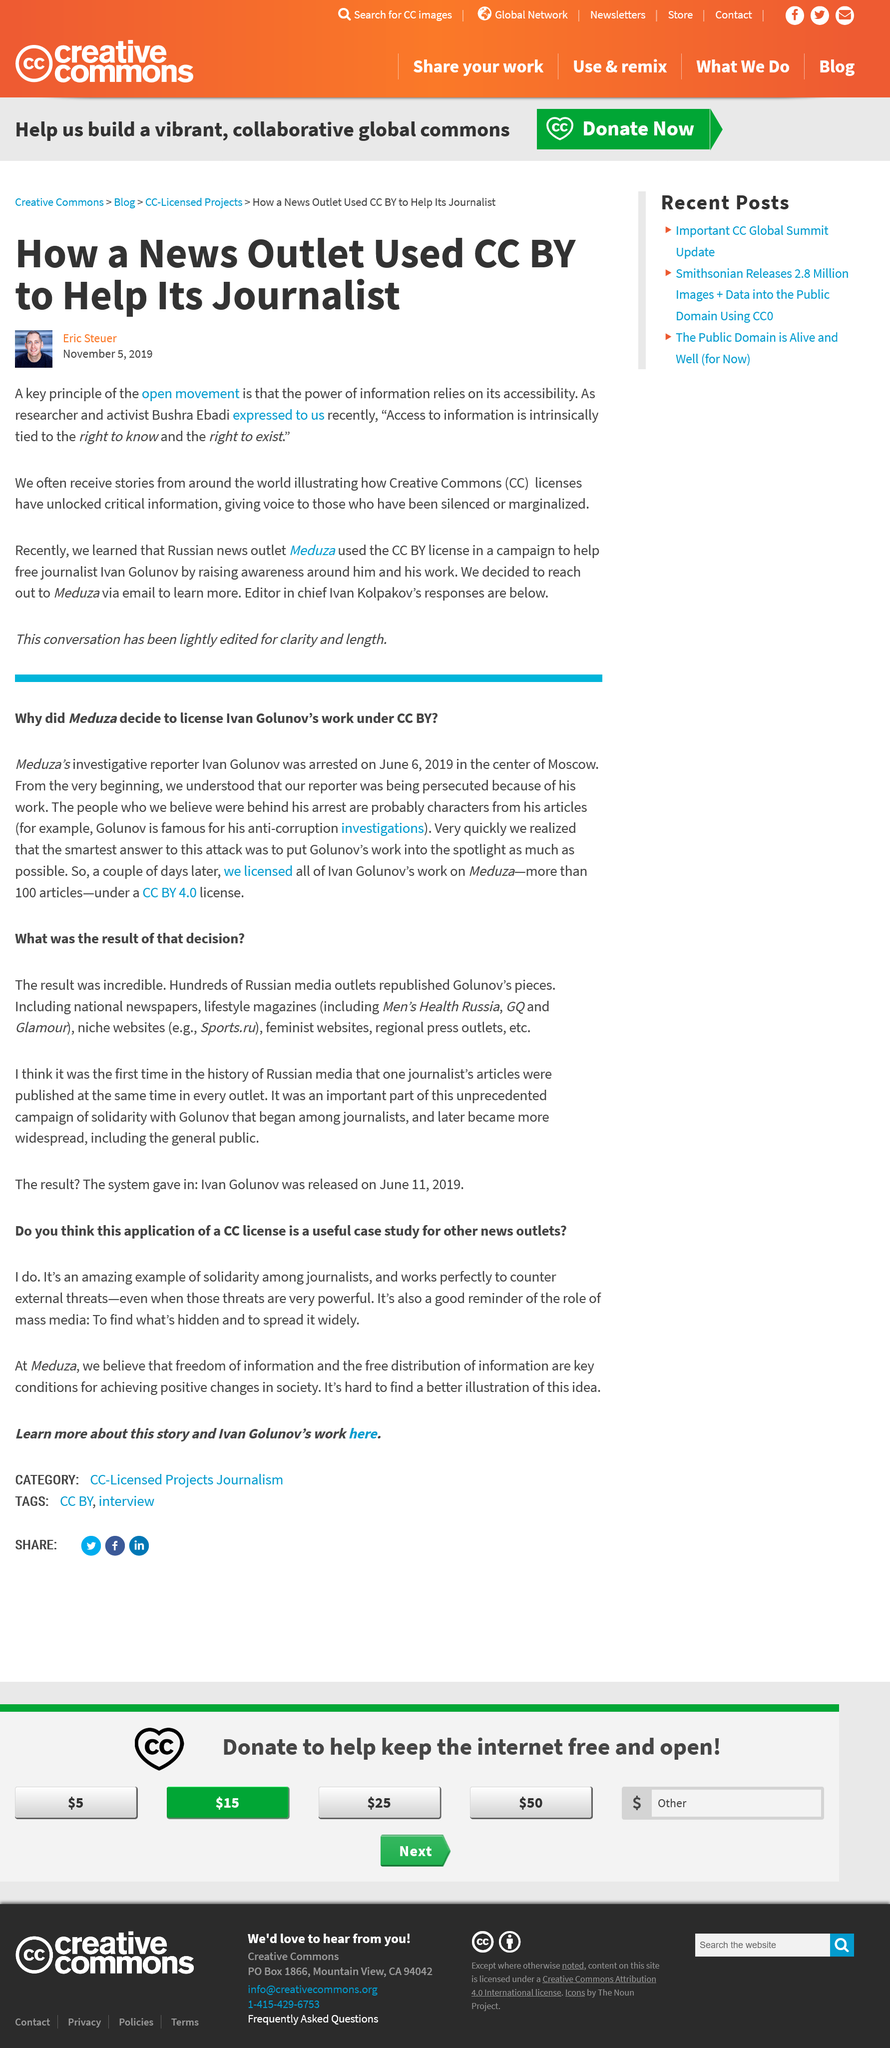Give some essential details in this illustration. Ivan is renowned for his outstanding achievements in uncovering corruption through his investigations. Ivan was arrested after an event occurred. Access to information is intrinsically tied to the fundamental rights to know and to exist, and is essential for the exercise of these rights and for the well-being of individuals and society as a whole. The researcher and activist referenced in the article is Bushra Ebadi. Ivan wrote over 100 articles. 